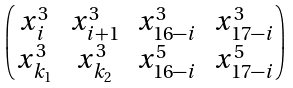Convert formula to latex. <formula><loc_0><loc_0><loc_500><loc_500>\begin{pmatrix} x _ { i } ^ { 3 } & x _ { i + 1 } ^ { 3 } & x _ { 1 6 - i } ^ { 3 } & x _ { 1 7 - i } ^ { 3 } \\ x _ { k _ { 1 } } ^ { 3 } & x _ { k _ { 2 } } ^ { 3 } & x _ { 1 6 - i } ^ { 5 } & x _ { 1 7 - i } ^ { 5 } \end{pmatrix}</formula> 